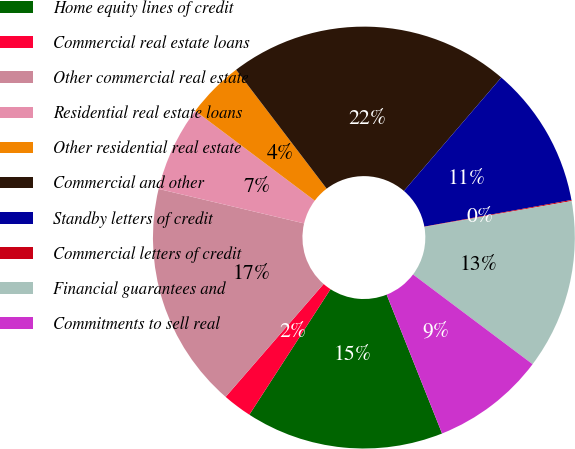<chart> <loc_0><loc_0><loc_500><loc_500><pie_chart><fcel>Home equity lines of credit<fcel>Commercial real estate loans<fcel>Other commercial real estate<fcel>Residential real estate loans<fcel>Other residential real estate<fcel>Commercial and other<fcel>Standby letters of credit<fcel>Commercial letters of credit<fcel>Financial guarantees and<fcel>Commitments to sell real<nl><fcel>15.18%<fcel>2.24%<fcel>17.33%<fcel>6.55%<fcel>4.39%<fcel>21.65%<fcel>10.86%<fcel>0.08%<fcel>13.02%<fcel>8.71%<nl></chart> 